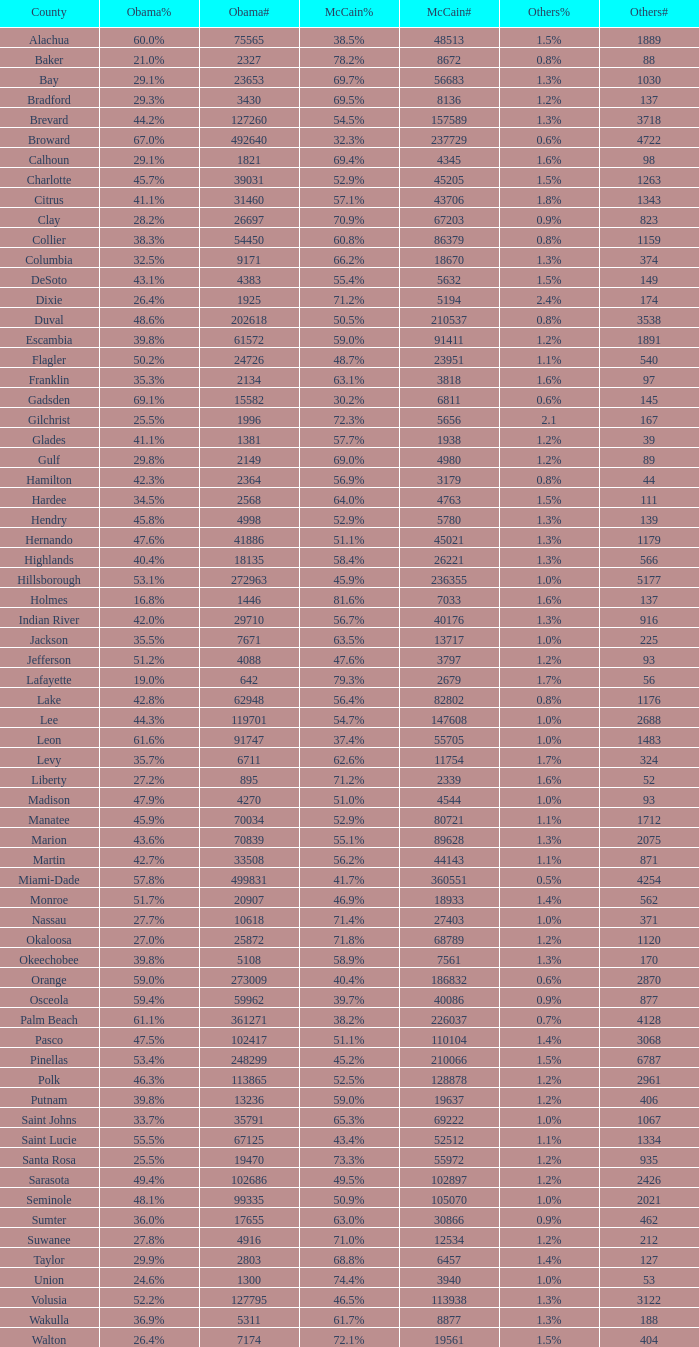What was the count of numbers under mccain when obama secured 27.2% votes? 1.0. 